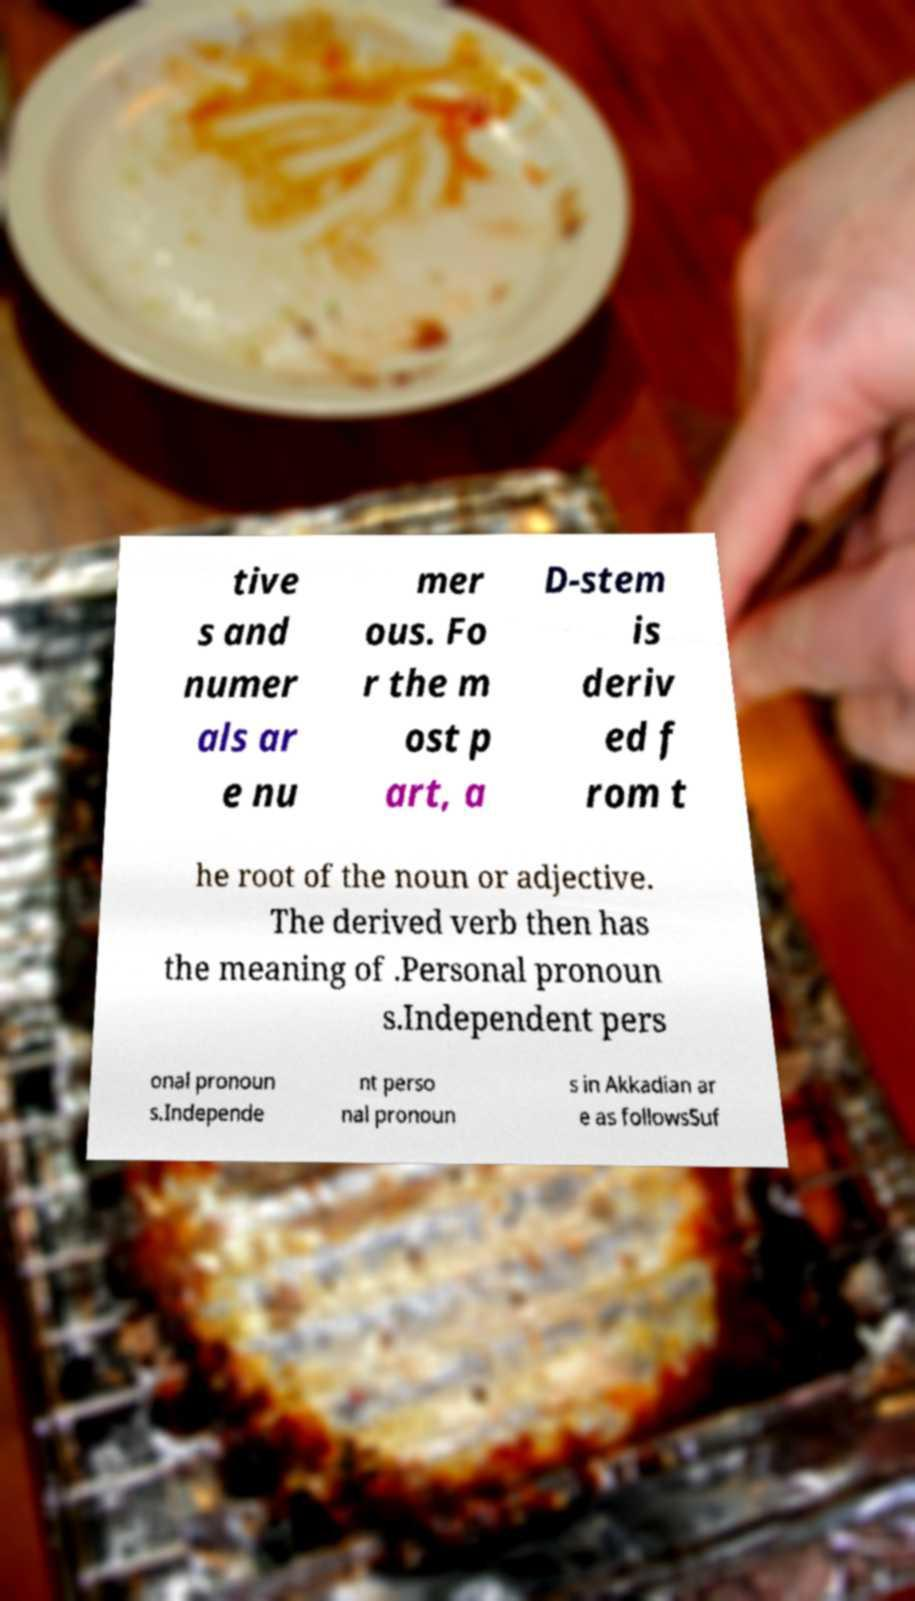There's text embedded in this image that I need extracted. Can you transcribe it verbatim? tive s and numer als ar e nu mer ous. Fo r the m ost p art, a D-stem is deriv ed f rom t he root of the noun or adjective. The derived verb then has the meaning of .Personal pronoun s.Independent pers onal pronoun s.Independe nt perso nal pronoun s in Akkadian ar e as followsSuf 